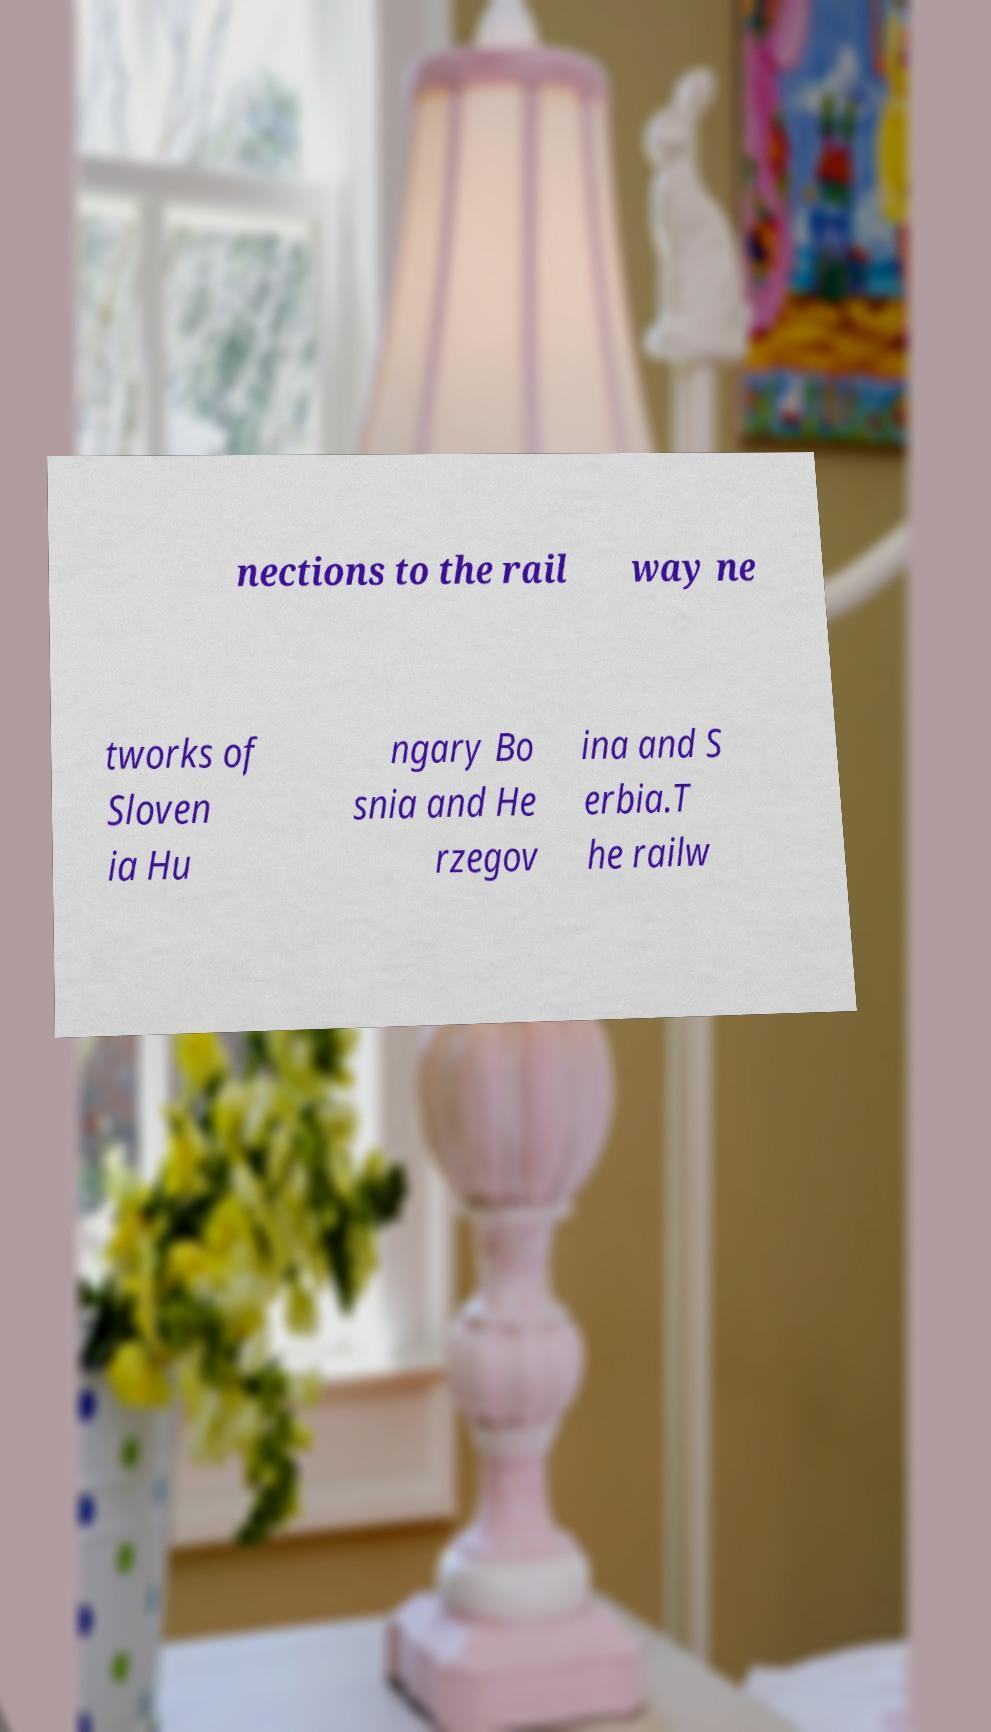Please identify and transcribe the text found in this image. nections to the rail way ne tworks of Sloven ia Hu ngary Bo snia and He rzegov ina and S erbia.T he railw 